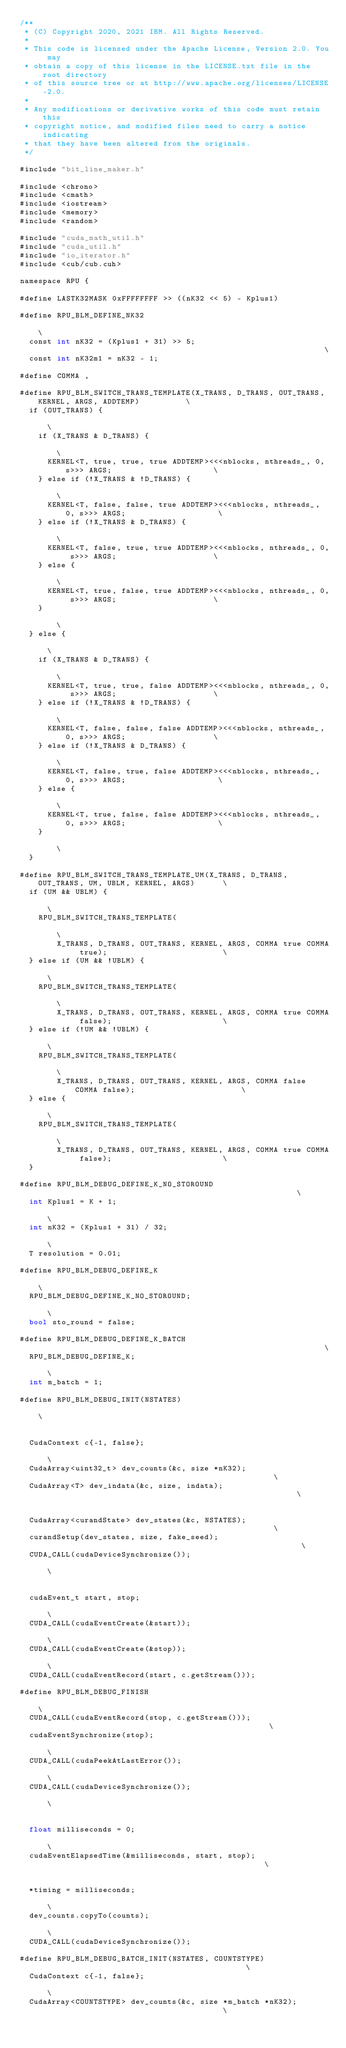<code> <loc_0><loc_0><loc_500><loc_500><_Cuda_>/**
 * (C) Copyright 2020, 2021 IBM. All Rights Reserved.
 *
 * This code is licensed under the Apache License, Version 2.0. You may
 * obtain a copy of this license in the LICENSE.txt file in the root directory
 * of this source tree or at http://www.apache.org/licenses/LICENSE-2.0.
 *
 * Any modifications or derivative works of this code must retain this
 * copyright notice, and modified files need to carry a notice indicating
 * that they have been altered from the originals.
 */

#include "bit_line_maker.h"

#include <chrono>
#include <cmath>
#include <iostream>
#include <memory>
#include <random>

#include "cuda_math_util.h"
#include "cuda_util.h"
#include "io_iterator.h"
#include <cub/cub.cuh>

namespace RPU {

#define LASTK32MASK 0xFFFFFFFF >> ((nK32 << 5) - Kplus1)

#define RPU_BLM_DEFINE_NK32                                                                        \
  const int nK32 = (Kplus1 + 31) >> 5;                                                             \
  const int nK32m1 = nK32 - 1;

#define COMMA ,

#define RPU_BLM_SWITCH_TRANS_TEMPLATE(X_TRANS, D_TRANS, OUT_TRANS, KERNEL, ARGS, ADDTEMP)          \
  if (OUT_TRANS) {                                                                                 \
    if (X_TRANS & D_TRANS) {                                                                       \
      KERNEL<T, true, true, true ADDTEMP><<<nblocks, nthreads_, 0, s>>> ARGS;                      \
    } else if (!X_TRANS & !D_TRANS) {                                                              \
      KERNEL<T, false, false, true ADDTEMP><<<nblocks, nthreads_, 0, s>>> ARGS;                    \
    } else if (!X_TRANS & D_TRANS) {                                                               \
      KERNEL<T, false, true, true ADDTEMP><<<nblocks, nthreads_, 0, s>>> ARGS;                     \
    } else {                                                                                       \
      KERNEL<T, true, false, true ADDTEMP><<<nblocks, nthreads_, 0, s>>> ARGS;                     \
    }                                                                                              \
  } else {                                                                                         \
    if (X_TRANS & D_TRANS) {                                                                       \
      KERNEL<T, true, true, false ADDTEMP><<<nblocks, nthreads_, 0, s>>> ARGS;                     \
    } else if (!X_TRANS & !D_TRANS) {                                                              \
      KERNEL<T, false, false, false ADDTEMP><<<nblocks, nthreads_, 0, s>>> ARGS;                   \
    } else if (!X_TRANS & D_TRANS) {                                                               \
      KERNEL<T, false, true, false ADDTEMP><<<nblocks, nthreads_, 0, s>>> ARGS;                    \
    } else {                                                                                       \
      KERNEL<T, true, false, false ADDTEMP><<<nblocks, nthreads_, 0, s>>> ARGS;                    \
    }                                                                                              \
  }

#define RPU_BLM_SWITCH_TRANS_TEMPLATE_UM(X_TRANS, D_TRANS, OUT_TRANS, UM, UBLM, KERNEL, ARGS)      \
  if (UM && UBLM) {                                                                                \
    RPU_BLM_SWITCH_TRANS_TEMPLATE(                                                                 \
        X_TRANS, D_TRANS, OUT_TRANS, KERNEL, ARGS, COMMA true COMMA true);                         \
  } else if (UM && !UBLM) {                                                                        \
    RPU_BLM_SWITCH_TRANS_TEMPLATE(                                                                 \
        X_TRANS, D_TRANS, OUT_TRANS, KERNEL, ARGS, COMMA true COMMA false);                        \
  } else if (!UM && !UBLM) {                                                                       \
    RPU_BLM_SWITCH_TRANS_TEMPLATE(                                                                 \
        X_TRANS, D_TRANS, OUT_TRANS, KERNEL, ARGS, COMMA false COMMA false);                       \
  } else {                                                                                         \
    RPU_BLM_SWITCH_TRANS_TEMPLATE(                                                                 \
        X_TRANS, D_TRANS, OUT_TRANS, KERNEL, ARGS, COMMA true COMMA false);                        \
  }

#define RPU_BLM_DEBUG_DEFINE_K_NO_STOROUND                                                         \
  int Kplus1 = K + 1;                                                                              \
  int nK32 = (Kplus1 + 31) / 32;                                                                   \
  T resolution = 0.01;

#define RPU_BLM_DEBUG_DEFINE_K                                                                     \
  RPU_BLM_DEBUG_DEFINE_K_NO_STOROUND;                                                              \
  bool sto_round = false;

#define RPU_BLM_DEBUG_DEFINE_K_BATCH                                                               \
  RPU_BLM_DEBUG_DEFINE_K;                                                                          \
  int m_batch = 1;

#define RPU_BLM_DEBUG_INIT(NSTATES)                                                                \
                                                                                                   \
  CudaContext c{-1, false};                                                                        \
  CudaArray<uint32_t> dev_counts(&c, size *nK32);                                                  \
  CudaArray<T> dev_indata(&c, size, indata);                                                       \
                                                                                                   \
  CudaArray<curandState> dev_states(&c, NSTATES);                                                  \
  curandSetup(dev_states, size, fake_seed);                                                        \
  CUDA_CALL(cudaDeviceSynchronize());                                                              \
                                                                                                   \
  cudaEvent_t start, stop;                                                                         \
  CUDA_CALL(cudaEventCreate(&start));                                                              \
  CUDA_CALL(cudaEventCreate(&stop));                                                               \
  CUDA_CALL(cudaEventRecord(start, c.getStream()));

#define RPU_BLM_DEBUG_FINISH                                                                       \
  CUDA_CALL(cudaEventRecord(stop, c.getStream()));                                                 \
  cudaEventSynchronize(stop);                                                                      \
  CUDA_CALL(cudaPeekAtLastError());                                                                \
  CUDA_CALL(cudaDeviceSynchronize());                                                              \
                                                                                                   \
  float milliseconds = 0;                                                                          \
  cudaEventElapsedTime(&milliseconds, start, stop);                                                \
                                                                                                   \
  *timing = milliseconds;                                                                          \
  dev_counts.copyTo(counts);                                                                       \
  CUDA_CALL(cudaDeviceSynchronize());

#define RPU_BLM_DEBUG_BATCH_INIT(NSTATES, COUNTSTYPE)                                              \
  CudaContext c{-1, false};                                                                        \
  CudaArray<COUNTSTYPE> dev_counts(&c, size *m_batch *nK32);                                       \</code> 